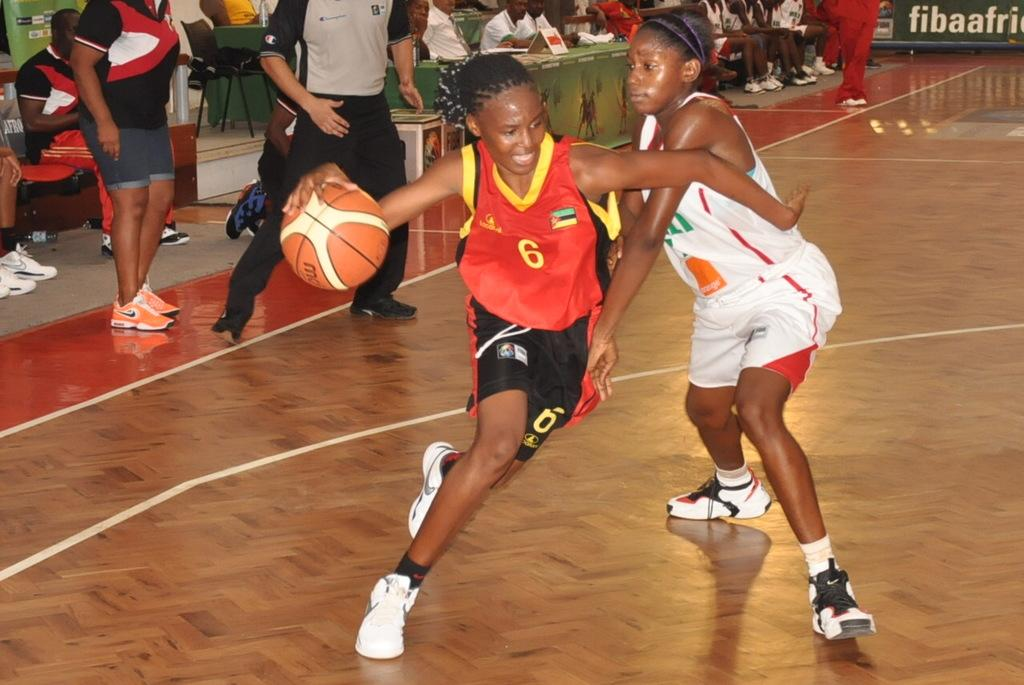<image>
Share a concise interpretation of the image provided. Two women competing in a basketball game in Africa for the FIBA AFRICA CUP. 